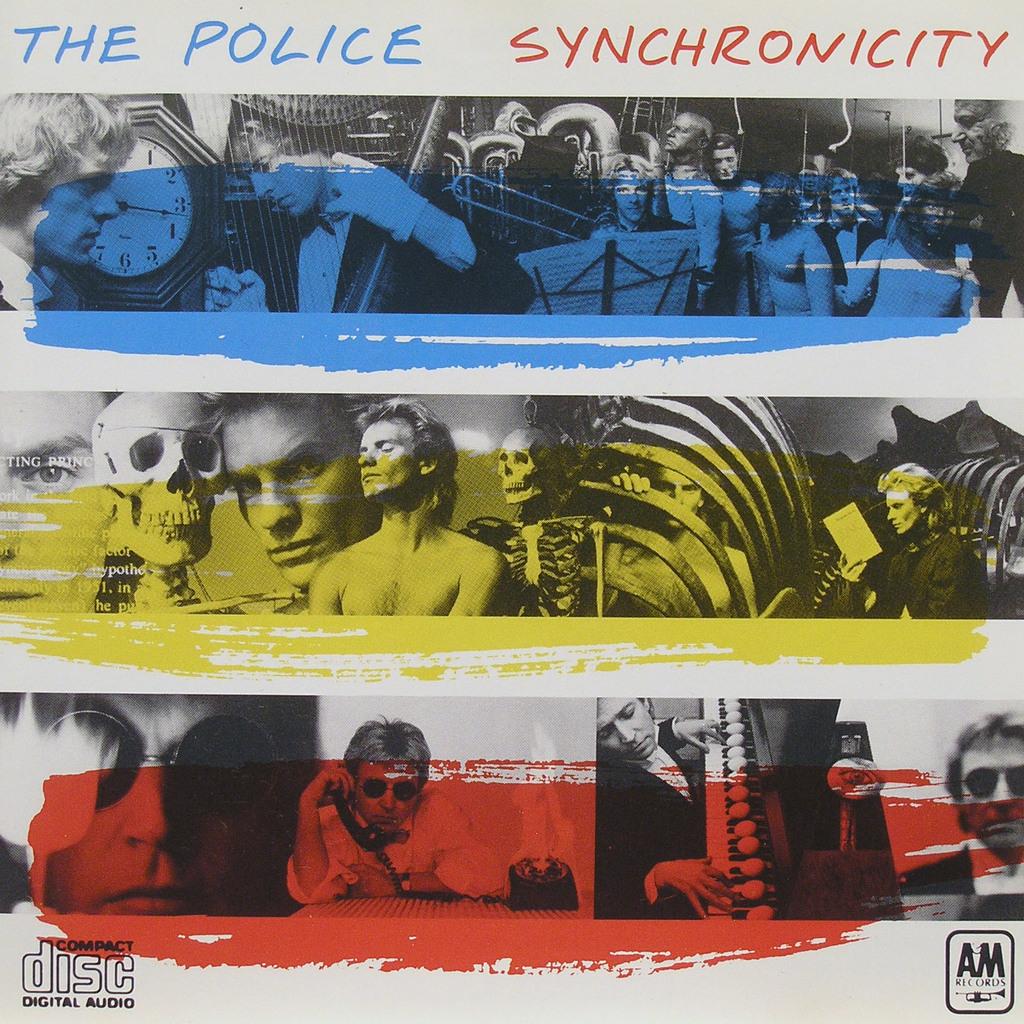What type of media is this?
Make the answer very short. Compact disc. Who is the artist?
Make the answer very short. The police. 